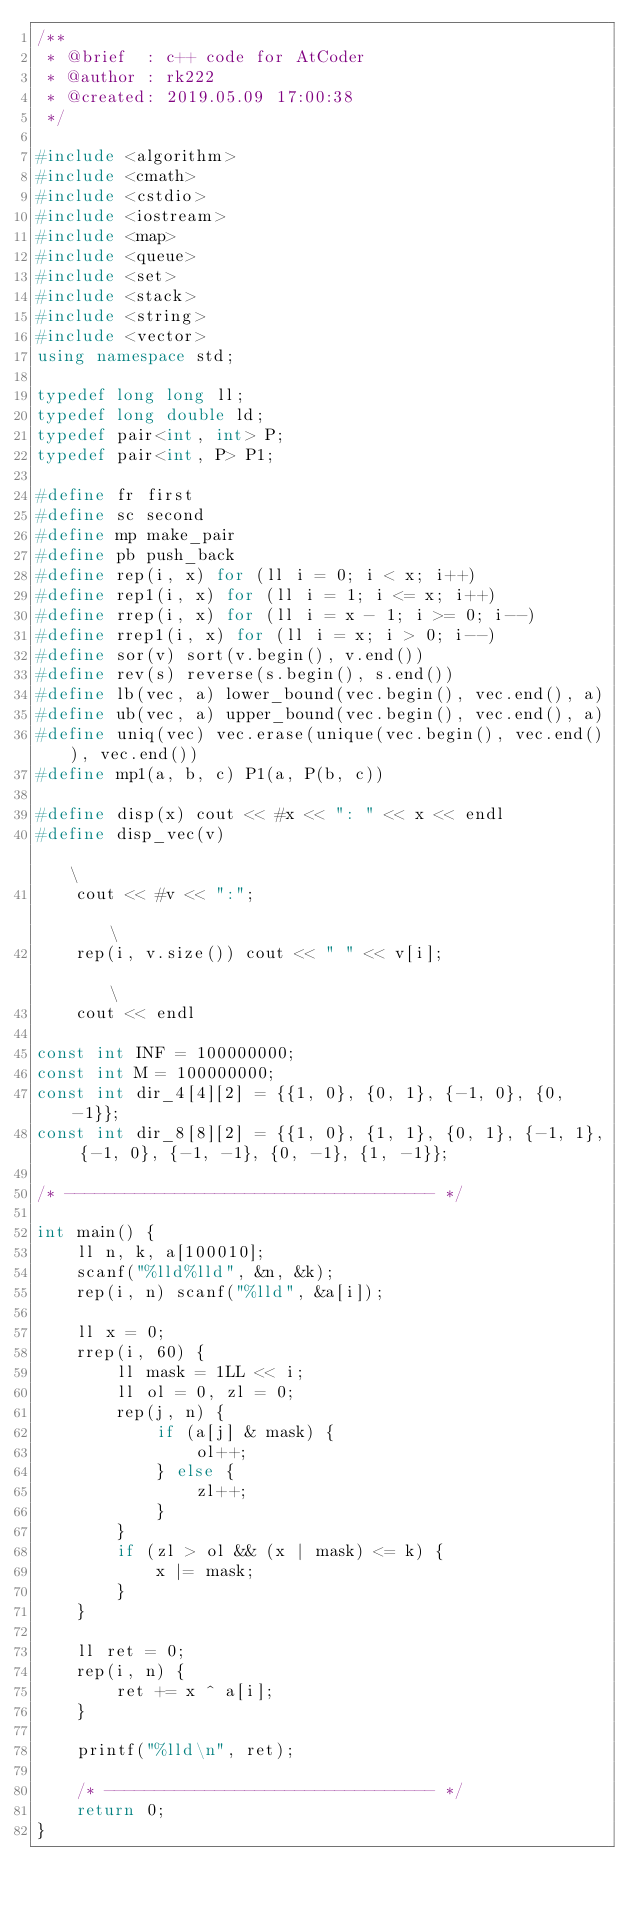<code> <loc_0><loc_0><loc_500><loc_500><_C++_>/**
 * @brief  : c++ code for AtCoder
 * @author : rk222
 * @created: 2019.05.09 17:00:38
 */

#include <algorithm>
#include <cmath>
#include <cstdio>
#include <iostream>
#include <map>
#include <queue>
#include <set>
#include <stack>
#include <string>
#include <vector>
using namespace std;

typedef long long ll;
typedef long double ld;
typedef pair<int, int> P;
typedef pair<int, P> P1;

#define fr first
#define sc second
#define mp make_pair
#define pb push_back
#define rep(i, x) for (ll i = 0; i < x; i++)
#define rep1(i, x) for (ll i = 1; i <= x; i++)
#define rrep(i, x) for (ll i = x - 1; i >= 0; i--)
#define rrep1(i, x) for (ll i = x; i > 0; i--)
#define sor(v) sort(v.begin(), v.end())
#define rev(s) reverse(s.begin(), s.end())
#define lb(vec, a) lower_bound(vec.begin(), vec.end(), a)
#define ub(vec, a) upper_bound(vec.begin(), vec.end(), a)
#define uniq(vec) vec.erase(unique(vec.begin(), vec.end()), vec.end())
#define mp1(a, b, c) P1(a, P(b, c))

#define disp(x) cout << #x << ": " << x << endl
#define disp_vec(v)                                                                           \
    cout << #v << ":";                                                                        \
    rep(i, v.size()) cout << " " << v[i];                                                     \
    cout << endl

const int INF = 100000000;
const int M = 100000000;
const int dir_4[4][2] = {{1, 0}, {0, 1}, {-1, 0}, {0, -1}};
const int dir_8[8][2] = {{1, 0}, {1, 1}, {0, 1}, {-1, 1}, {-1, 0}, {-1, -1}, {0, -1}, {1, -1}};

/* ------------------------------------- */

int main() {
    ll n, k, a[100010];
    scanf("%lld%lld", &n, &k);
    rep(i, n) scanf("%lld", &a[i]);

    ll x = 0;
    rrep(i, 60) {
        ll mask = 1LL << i;
        ll ol = 0, zl = 0;
        rep(j, n) {
            if (a[j] & mask) {
                ol++;
            } else {
                zl++;
            }
        }
        if (zl > ol && (x | mask) <= k) {
            x |= mask;
        }
    }

    ll ret = 0;
    rep(i, n) {
        ret += x ^ a[i];
    }

    printf("%lld\n", ret);

    /* --------------------------------- */
    return 0;
}</code> 